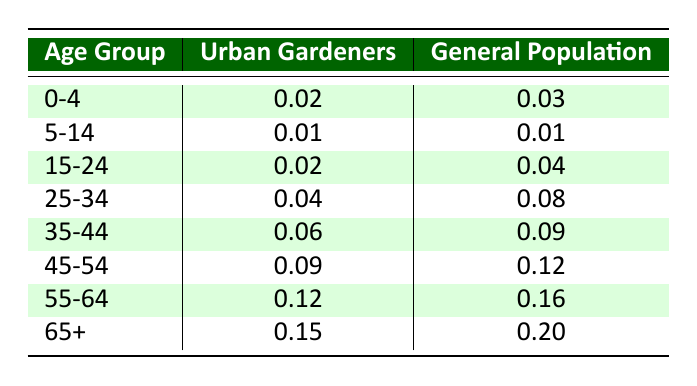What is the mortality rate for urban gardeners in the age group 25-34? From the table, the mortality rate for urban gardeners in the age group 25-34 is directly listed as 0.04.
Answer: 0.04 What is the mortality rate for the general population in the age group 55-64? The table shows that the mortality rate for the general population in the age group 55-64 is 0.16.
Answer: 0.16 Is the mortality rate for urban gardeners lower in the age group 5-14 compared to the general population? In the age group 5-14, both urban gardeners and the general population have a mortality rate of 0.01. Therefore, the mortality rate for urban gardeners is not lower than that of the general population.
Answer: No What is the difference in mortality rates between urban gardeners and the general population for the age group 65+? The mortality rate for urban gardeners in the age group 65+ is 0.15, while for the general population, it is 0.20. The difference is calculated as 0.20 - 0.15 = 0.05.
Answer: 0.05 What is the highest mortality rate among urban gardeners and which age group does it belong to? Reviewing the table, the highest mortality rate for urban gardeners is 0.15 in the age group 65+.
Answer: 0.15, Age group 65+ What is the average mortality rate for urban gardeners across all age groups? To find the average, sum the mortality rates (0.02 + 0.01 + 0.02 + 0.04 + 0.06 + 0.09 + 0.12 + 0.15 = 0.51) and divide by the number of age groups (8). The average is 0.51 / 8 = 0.06375.
Answer: 0.06375 Has the mortality rate for the general population increased as age increases? Reviewing the table, each subsequent age group shows a higher mortality rate: 0.03, 0.01, 0.04, 0.08, 0.09, 0.12, 0.16, and 0.20. This indicates an increasing trend.
Answer: Yes Which age group has the largest difference in mortality rates between urban gardeners and the general population? Comparing the differences, the largest is in the age group 25-34: 0.08 - 0.04 = 0.04, as well as age group 45-54: 0.12 - 0.09 = 0.03, the highest difference is 0.05 in the age group 65+.
Answer: Age group 65+ with a difference of 0.05 